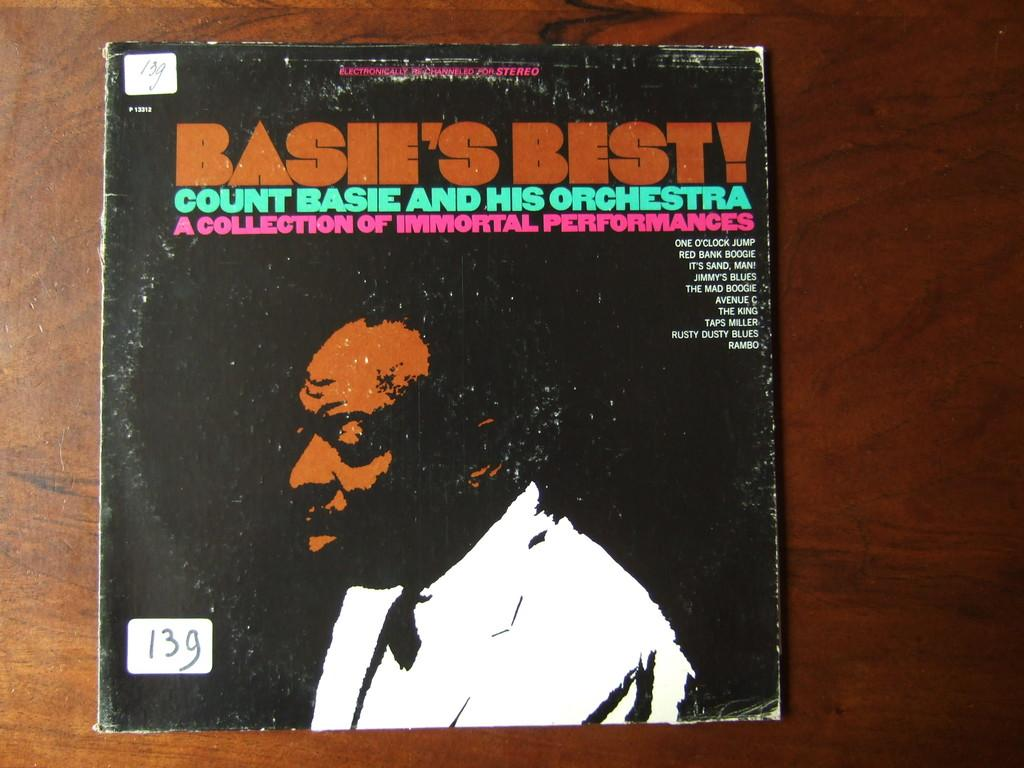<image>
Relay a brief, clear account of the picture shown. An album with Basie's Best has brown, green and pink letters on the front cover. 